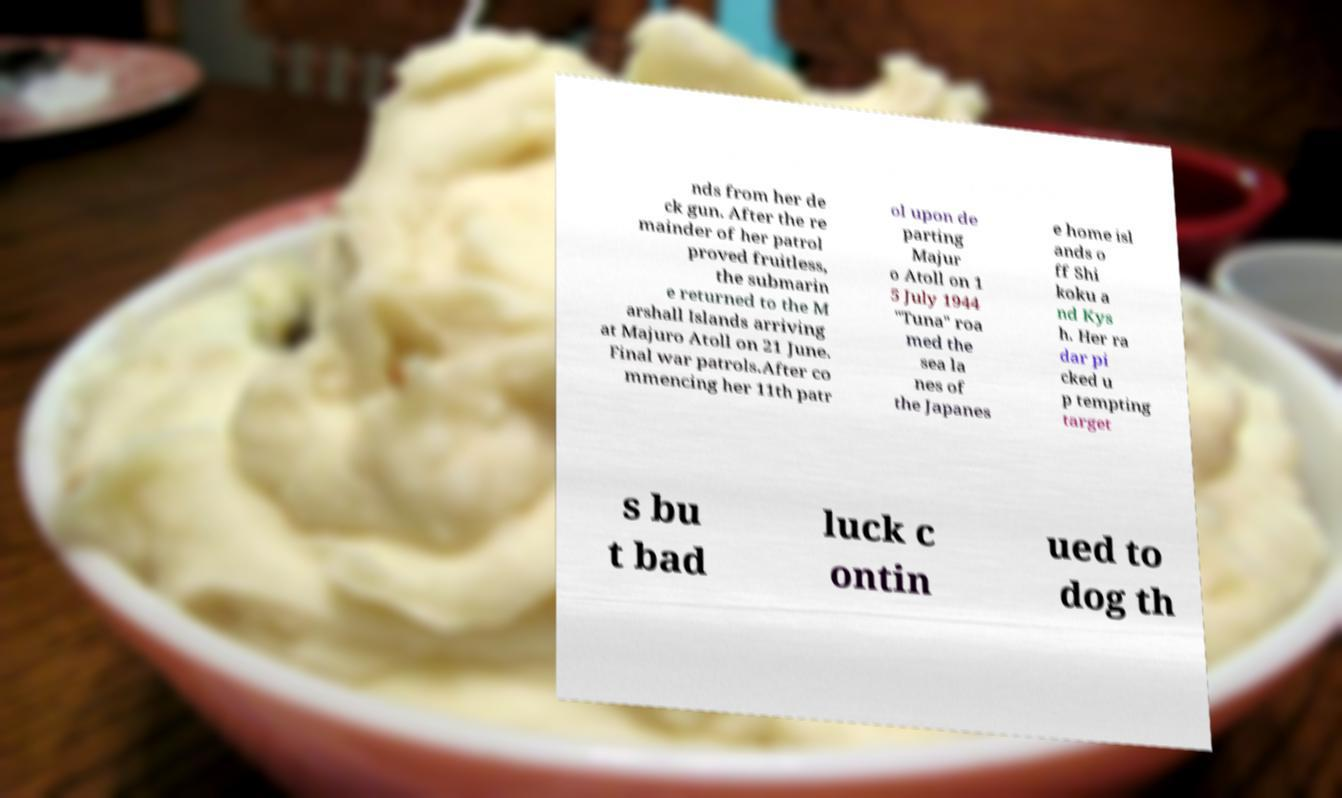Could you assist in decoding the text presented in this image and type it out clearly? nds from her de ck gun. After the re mainder of her patrol proved fruitless, the submarin e returned to the M arshall Islands arriving at Majuro Atoll on 21 June. Final war patrols.After co mmencing her 11th patr ol upon de parting Majur o Atoll on 1 5 July 1944 "Tuna" roa med the sea la nes of the Japanes e home isl ands o ff Shi koku a nd Kys h. Her ra dar pi cked u p tempting target s bu t bad luck c ontin ued to dog th 